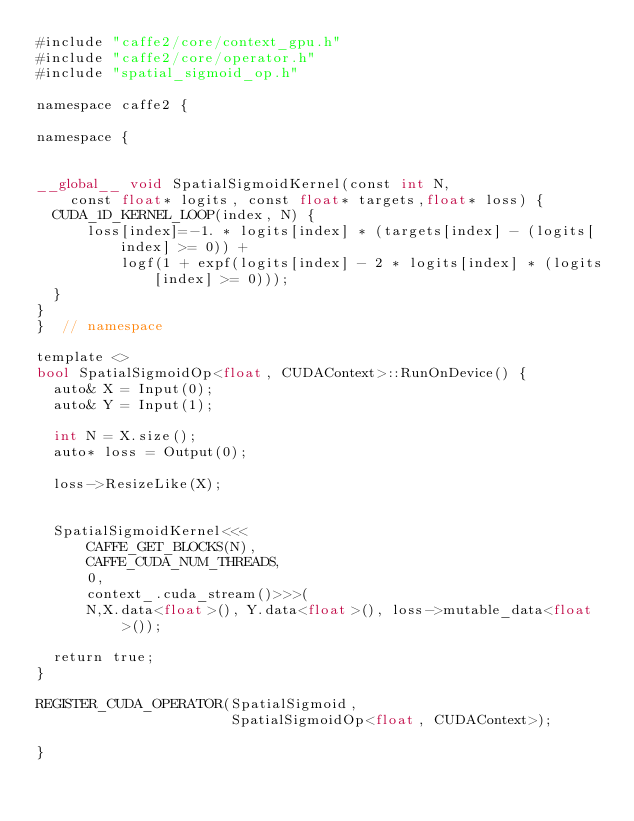Convert code to text. <code><loc_0><loc_0><loc_500><loc_500><_Cuda_>#include "caffe2/core/context_gpu.h"
#include "caffe2/core/operator.h"
#include "spatial_sigmoid_op.h"

namespace caffe2 {

namespace {


__global__ void SpatialSigmoidKernel(const int N,
    const float* logits, const float* targets,float* loss) {
  CUDA_1D_KERNEL_LOOP(index, N) {
      loss[index]=-1. * logits[index] * (targets[index] - (logits[index] >= 0)) +
          logf(1 + expf(logits[index] - 2 * logits[index] * (logits[index] >= 0)));
  }
}
}  // namespace

template <>
bool SpatialSigmoidOp<float, CUDAContext>::RunOnDevice() {
  auto& X = Input(0);
  auto& Y = Input(1);
  
  int N = X.size();
  auto* loss = Output(0);

  loss->ResizeLike(X);


  SpatialSigmoidKernel<<<
      CAFFE_GET_BLOCKS(N),
      CAFFE_CUDA_NUM_THREADS,
      0,
      context_.cuda_stream()>>>(
      N,X.data<float>(), Y.data<float>(), loss->mutable_data<float>());

  return true;
}

REGISTER_CUDA_OPERATOR(SpatialSigmoid,
                       SpatialSigmoidOp<float, CUDAContext>);

}</code> 